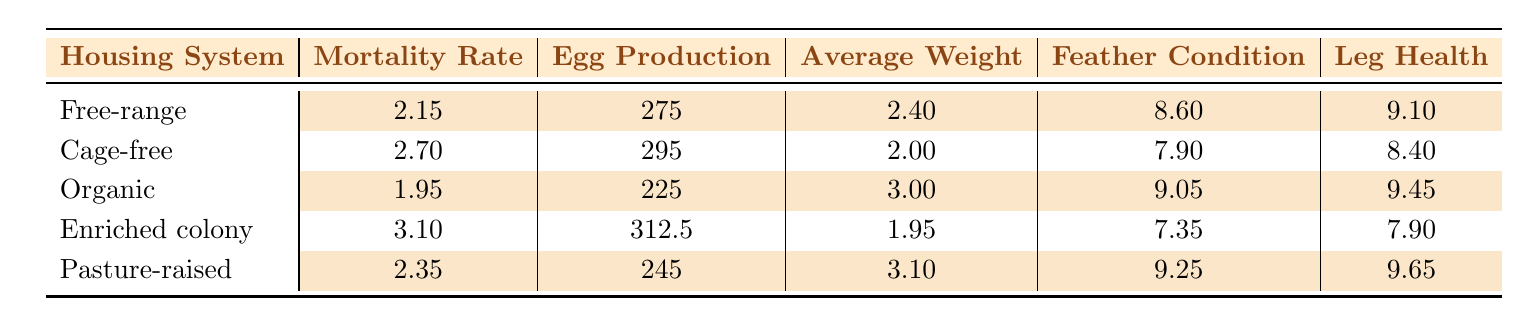what is the mortality rate for the Free-range housing system? The table shows the Free-range row, where the mortality rate is listed as 2.15.
Answer: 2.15 which housing system has the highest average weight? The table shows that the Organic housing system has the highest average weight of 3.00, compared to others.
Answer: 3.00 what is the average egg production for the Cage-free housing system? From the table, the Cage-free row indicates that the average egg production is 295.
Answer: 295 is the mortality rate for Organic chickens lower than that for Enriched colony chickens? The table provides mortality rates of 1.95 for Organic and 3.10 for Enriched colony. Since 1.95 is less than 3.10, the statement is true.
Answer: Yes what is the average mortality rate across all housing systems? To find the average mortality rate, sum the rates: 2.15 + 2.70 + 1.95 + 3.10 + 2.35 = 12.25. Then divide by the number of systems (5), which gives 12.25 / 5 = 2.45.
Answer: 2.45 how does the average feather condition of Cage-free compare to Free-range? The average feather condition for Cage-free is 7.90, while for Free-range it is 8.60. Since 7.90 is less than 8.60, Cage-free has lower feather condition.
Answer: Lower what is the total egg production for the Pasture-raised and Organic housing systems combined? The table lists egg production for Pasture-raised as 245 and for Organic as 225. Adding these gives 245 + 225 = 470.
Answer: 470 is it true that all housing systems have a leg health rating above 8? Checking the table, Cage-free has a leg health rating of 8.40, and Enriched colony is at 7.90, which is below 8. Therefore, not all systems meet this criterion.
Answer: No which housing system has the lowest average egg production? Upon evaluating the table, the Organic system has the lowest average egg production at 225.
Answer: 225 